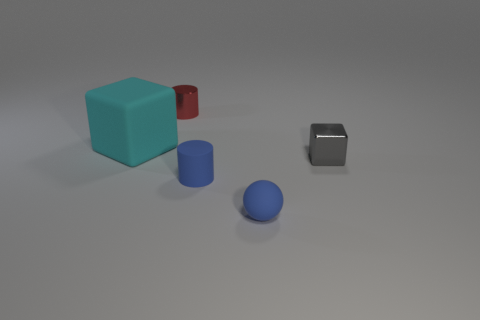Add 1 small shiny cylinders. How many objects exist? 6 Subtract all cylinders. How many objects are left? 3 Add 5 big cyan matte objects. How many big cyan matte objects are left? 6 Add 1 small blue cylinders. How many small blue cylinders exist? 2 Subtract 0 purple cylinders. How many objects are left? 5 Subtract all tiny metallic cylinders. Subtract all yellow metal cubes. How many objects are left? 4 